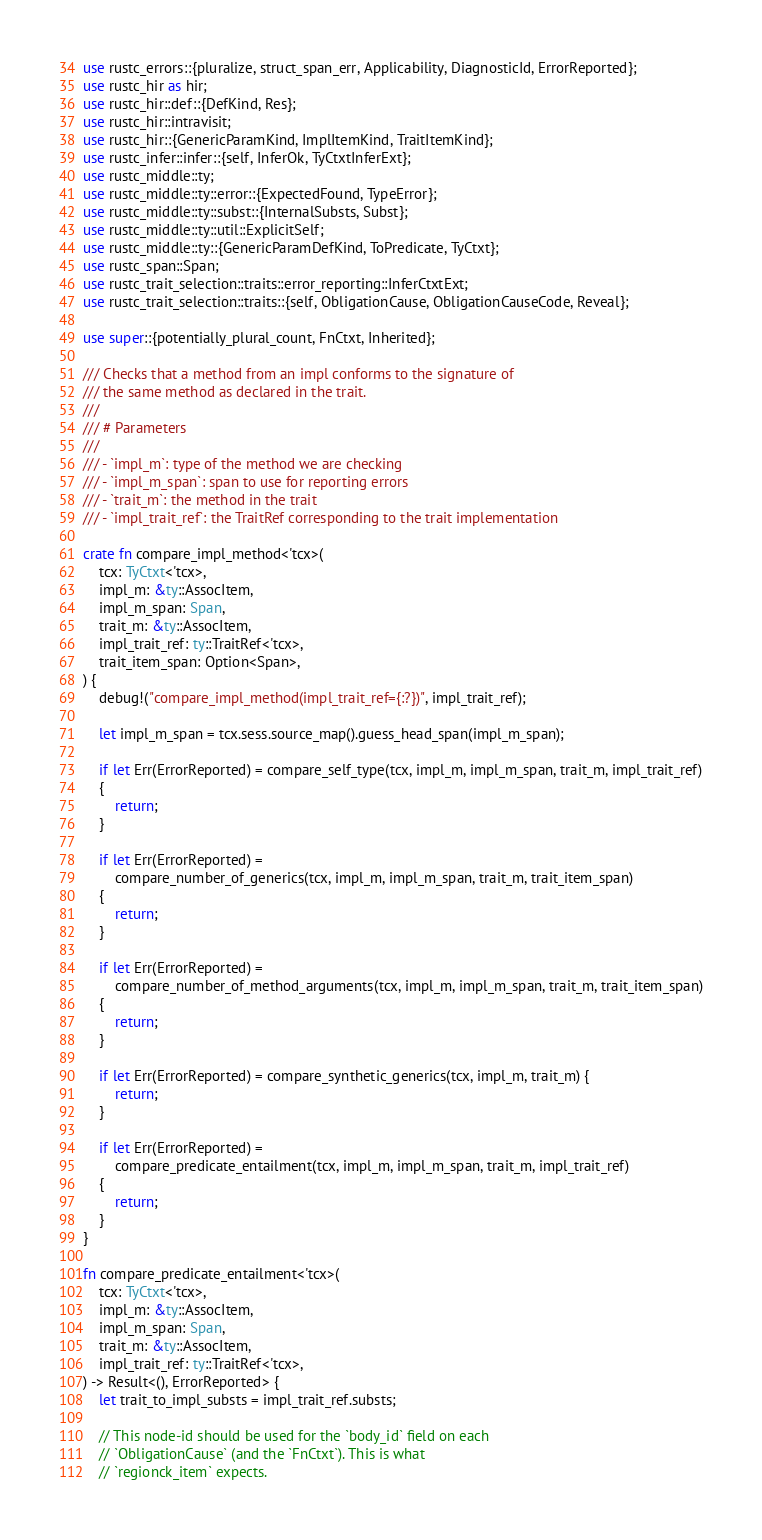<code> <loc_0><loc_0><loc_500><loc_500><_Rust_>use rustc_errors::{pluralize, struct_span_err, Applicability, DiagnosticId, ErrorReported};
use rustc_hir as hir;
use rustc_hir::def::{DefKind, Res};
use rustc_hir::intravisit;
use rustc_hir::{GenericParamKind, ImplItemKind, TraitItemKind};
use rustc_infer::infer::{self, InferOk, TyCtxtInferExt};
use rustc_middle::ty;
use rustc_middle::ty::error::{ExpectedFound, TypeError};
use rustc_middle::ty::subst::{InternalSubsts, Subst};
use rustc_middle::ty::util::ExplicitSelf;
use rustc_middle::ty::{GenericParamDefKind, ToPredicate, TyCtxt};
use rustc_span::Span;
use rustc_trait_selection::traits::error_reporting::InferCtxtExt;
use rustc_trait_selection::traits::{self, ObligationCause, ObligationCauseCode, Reveal};

use super::{potentially_plural_count, FnCtxt, Inherited};

/// Checks that a method from an impl conforms to the signature of
/// the same method as declared in the trait.
///
/// # Parameters
///
/// - `impl_m`: type of the method we are checking
/// - `impl_m_span`: span to use for reporting errors
/// - `trait_m`: the method in the trait
/// - `impl_trait_ref`: the TraitRef corresponding to the trait implementation

crate fn compare_impl_method<'tcx>(
    tcx: TyCtxt<'tcx>,
    impl_m: &ty::AssocItem,
    impl_m_span: Span,
    trait_m: &ty::AssocItem,
    impl_trait_ref: ty::TraitRef<'tcx>,
    trait_item_span: Option<Span>,
) {
    debug!("compare_impl_method(impl_trait_ref={:?})", impl_trait_ref);

    let impl_m_span = tcx.sess.source_map().guess_head_span(impl_m_span);

    if let Err(ErrorReported) = compare_self_type(tcx, impl_m, impl_m_span, trait_m, impl_trait_ref)
    {
        return;
    }

    if let Err(ErrorReported) =
        compare_number_of_generics(tcx, impl_m, impl_m_span, trait_m, trait_item_span)
    {
        return;
    }

    if let Err(ErrorReported) =
        compare_number_of_method_arguments(tcx, impl_m, impl_m_span, trait_m, trait_item_span)
    {
        return;
    }

    if let Err(ErrorReported) = compare_synthetic_generics(tcx, impl_m, trait_m) {
        return;
    }

    if let Err(ErrorReported) =
        compare_predicate_entailment(tcx, impl_m, impl_m_span, trait_m, impl_trait_ref)
    {
        return;
    }
}

fn compare_predicate_entailment<'tcx>(
    tcx: TyCtxt<'tcx>,
    impl_m: &ty::AssocItem,
    impl_m_span: Span,
    trait_m: &ty::AssocItem,
    impl_trait_ref: ty::TraitRef<'tcx>,
) -> Result<(), ErrorReported> {
    let trait_to_impl_substs = impl_trait_ref.substs;

    // This node-id should be used for the `body_id` field on each
    // `ObligationCause` (and the `FnCtxt`). This is what
    // `regionck_item` expects.</code> 